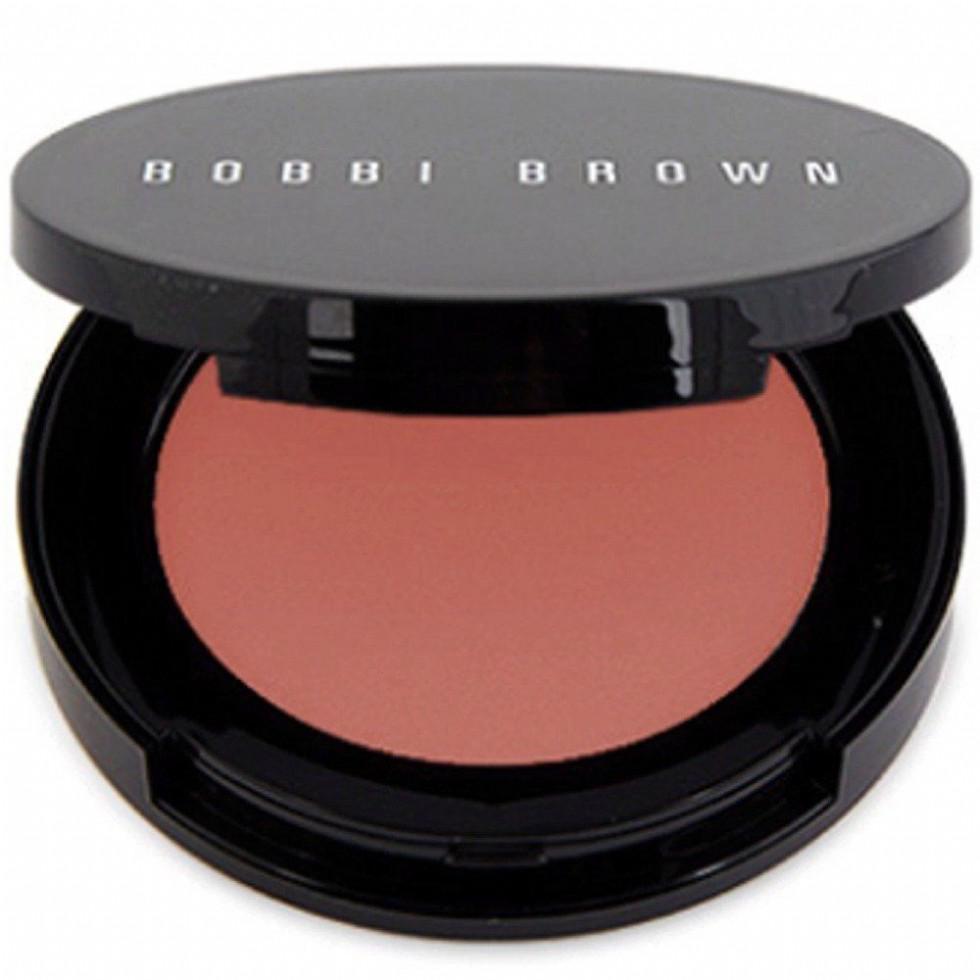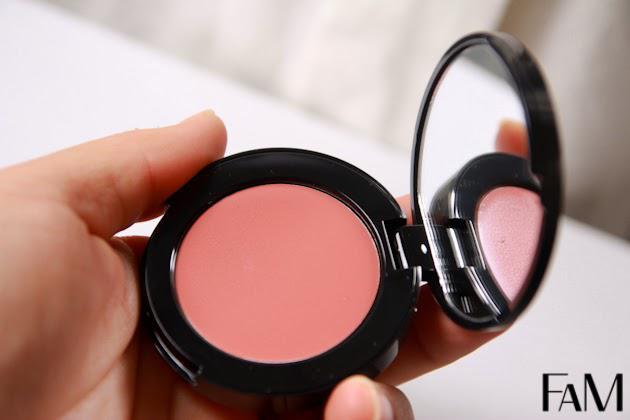The first image is the image on the left, the second image is the image on the right. Analyze the images presented: Is the assertion "There is at most 1 hand holding reddish makeup." valid? Answer yes or no. Yes. 